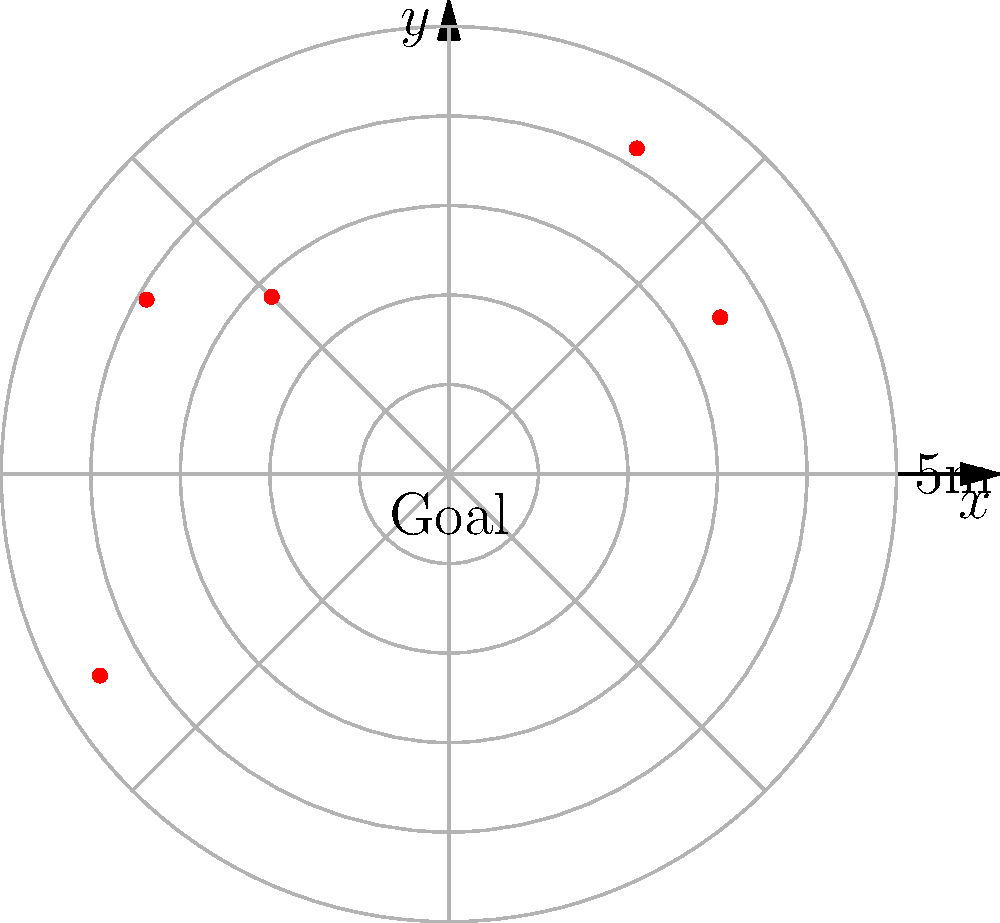As a soccer coach using statistical analysis, you're evaluating shot accuracy using a polar coordinate system centered on the goal. The diagram shows 5 shots plotted on this system, where the radial coordinate represents the distance from the goal in meters, and the angular coordinate represents the angle from the positive x-axis. What is the average (mean) distance of these shots from the goal, rounded to one decimal place? To solve this problem, we'll follow these steps:

1. Identify the radial coordinates (distances) of each shot from the goal.
2. Calculate the sum of these distances.
3. Divide the sum by the number of shots to get the average.
4. Round the result to one decimal place.

Step 1: Identify the radial coordinates
From the polar plot, we can see the following distances:
Shot 1: 3.5m
Shot 2: 4.2m
Shot 3: 2.8m
Shot 4: 3.9m
Shot 5: 4.5m

Step 2: Calculate the sum of distances
Sum = 3.5 + 4.2 + 2.8 + 3.9 + 4.5 = 18.9m

Step 3: Calculate the average
Average = Sum ÷ Number of shots
Average = 18.9 ÷ 5 = 3.78m

Step 4: Round to one decimal place
3.78m rounds to 3.8m

Therefore, the average distance of the shots from the goal is 3.8m.
Answer: 3.8m 